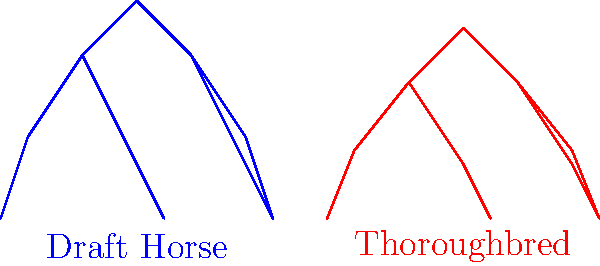Analyze the skeletal structures of the Draft horse (blue) and Thoroughbred (red) depicted in the image. Which breed is more likely to excel in high-speed racing, and why? To determine which breed is more likely to excel in high-speed racing, we need to analyze the skeletal structures:

1. Overall body shape:
   - Draft horse: Stockier, more compact build
   - Thoroughbred: Leaner, more elongated build

2. Leg length and angle:
   - Draft horse: Shorter legs with a more vertical angle
   - Thoroughbred: Longer legs with a more angled position

3. Chest and shoulder area:
   - Draft horse: Broader, more robust chest
   - Thoroughbred: Narrower, more streamlined chest

4. Back and hindquarters:
   - Draft horse: Shorter back, more powerful hindquarters
   - Thoroughbred: Longer back, more flexible spine

5. Biomechanical efficiency:
   - Thoroughbred's structure allows for:
     a) Longer stride length
     b) Increased flexibility
     c) Better aerodynamics

6. Energy expenditure:
   - Thoroughbred's lighter build requires less energy to maintain high speeds

Based on these observations, the Thoroughbred's skeletal structure is more adapted for high-speed racing. The longer legs, angled body position, and streamlined build contribute to greater speed and efficiency over short to medium distances.
Answer: Thoroughbred 